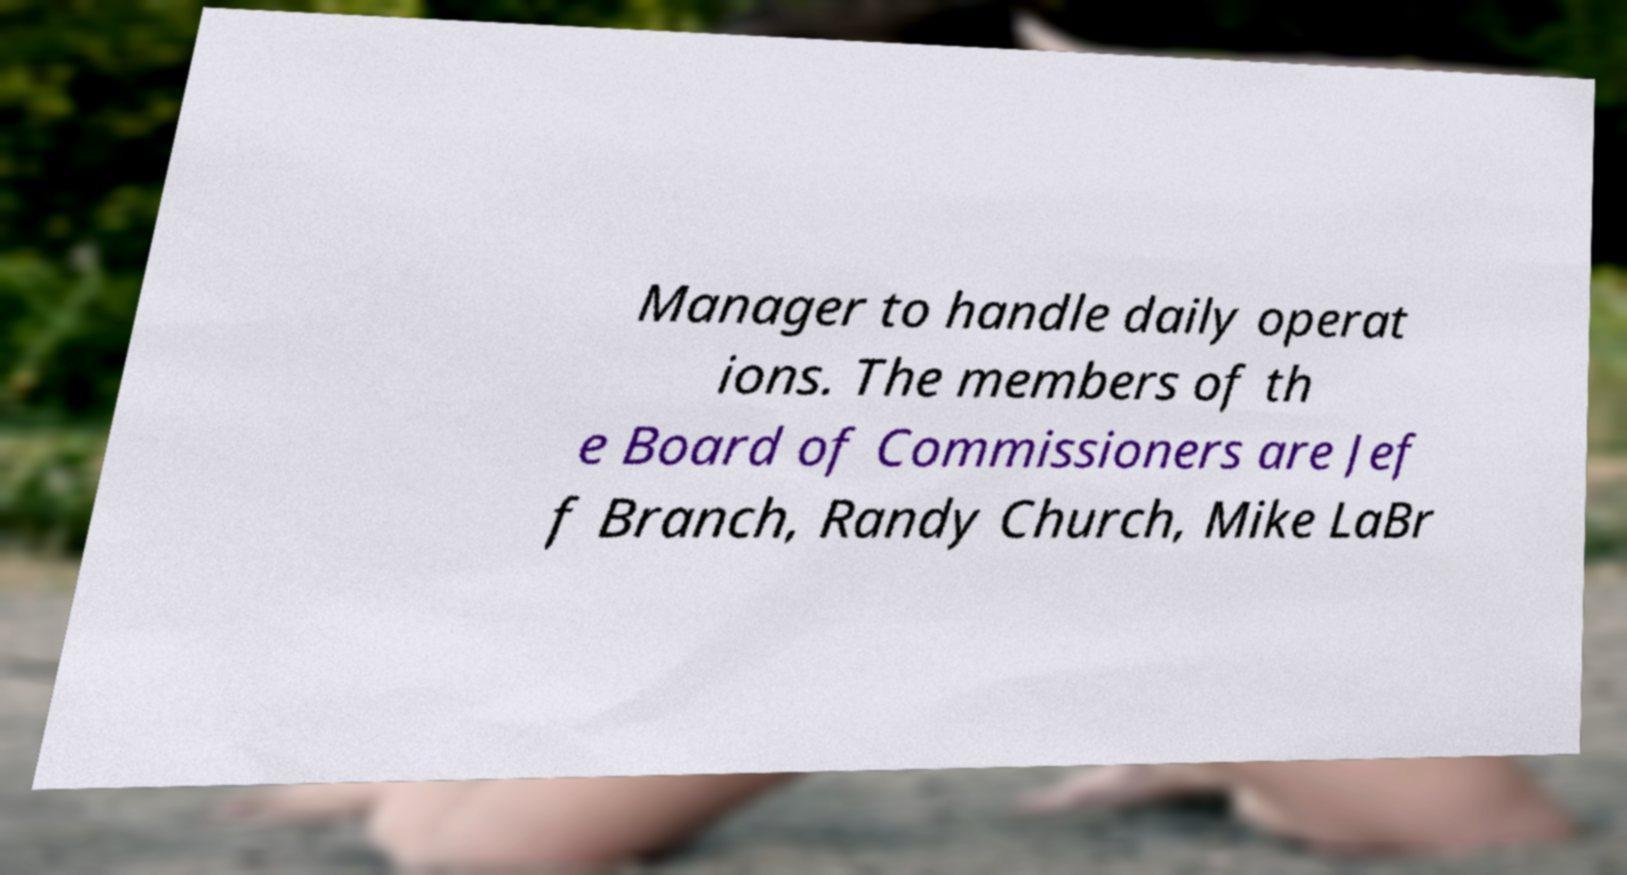Could you assist in decoding the text presented in this image and type it out clearly? Manager to handle daily operat ions. The members of th e Board of Commissioners are Jef f Branch, Randy Church, Mike LaBr 